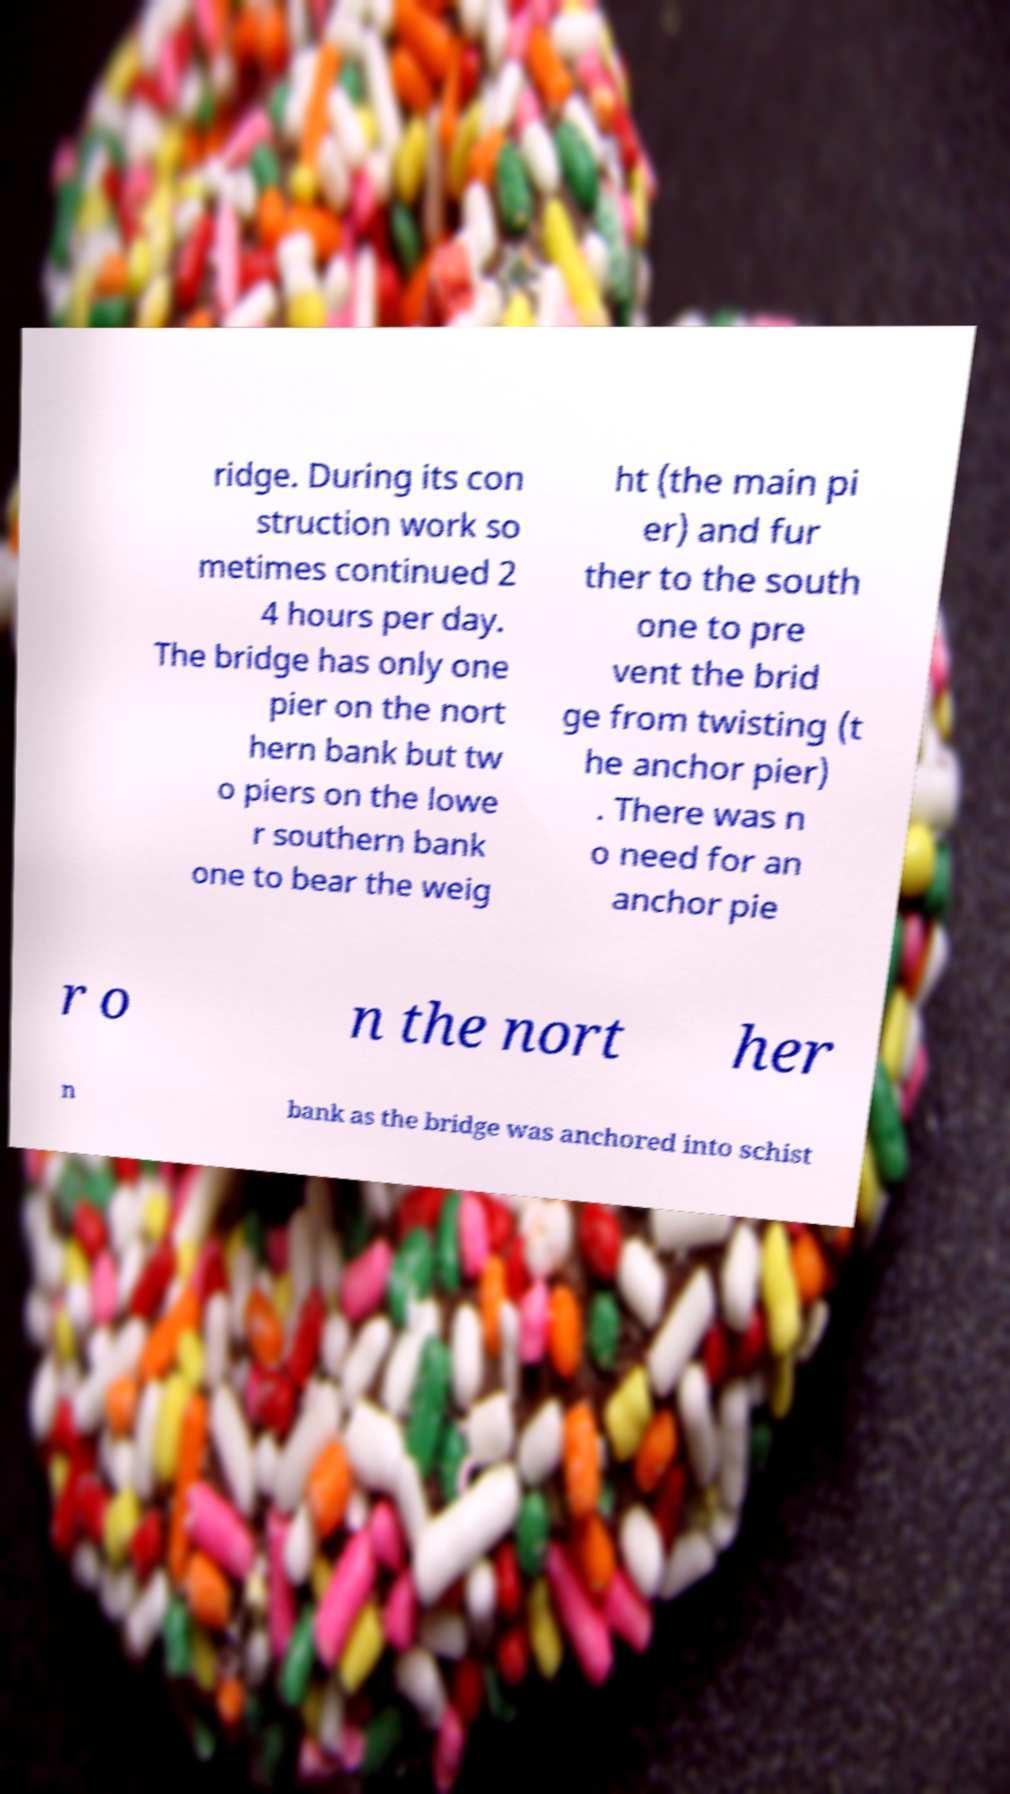Could you extract and type out the text from this image? ridge. During its con struction work so metimes continued 2 4 hours per day. The bridge has only one pier on the nort hern bank but tw o piers on the lowe r southern bank one to bear the weig ht (the main pi er) and fur ther to the south one to pre vent the brid ge from twisting (t he anchor pier) . There was n o need for an anchor pie r o n the nort her n bank as the bridge was anchored into schist 